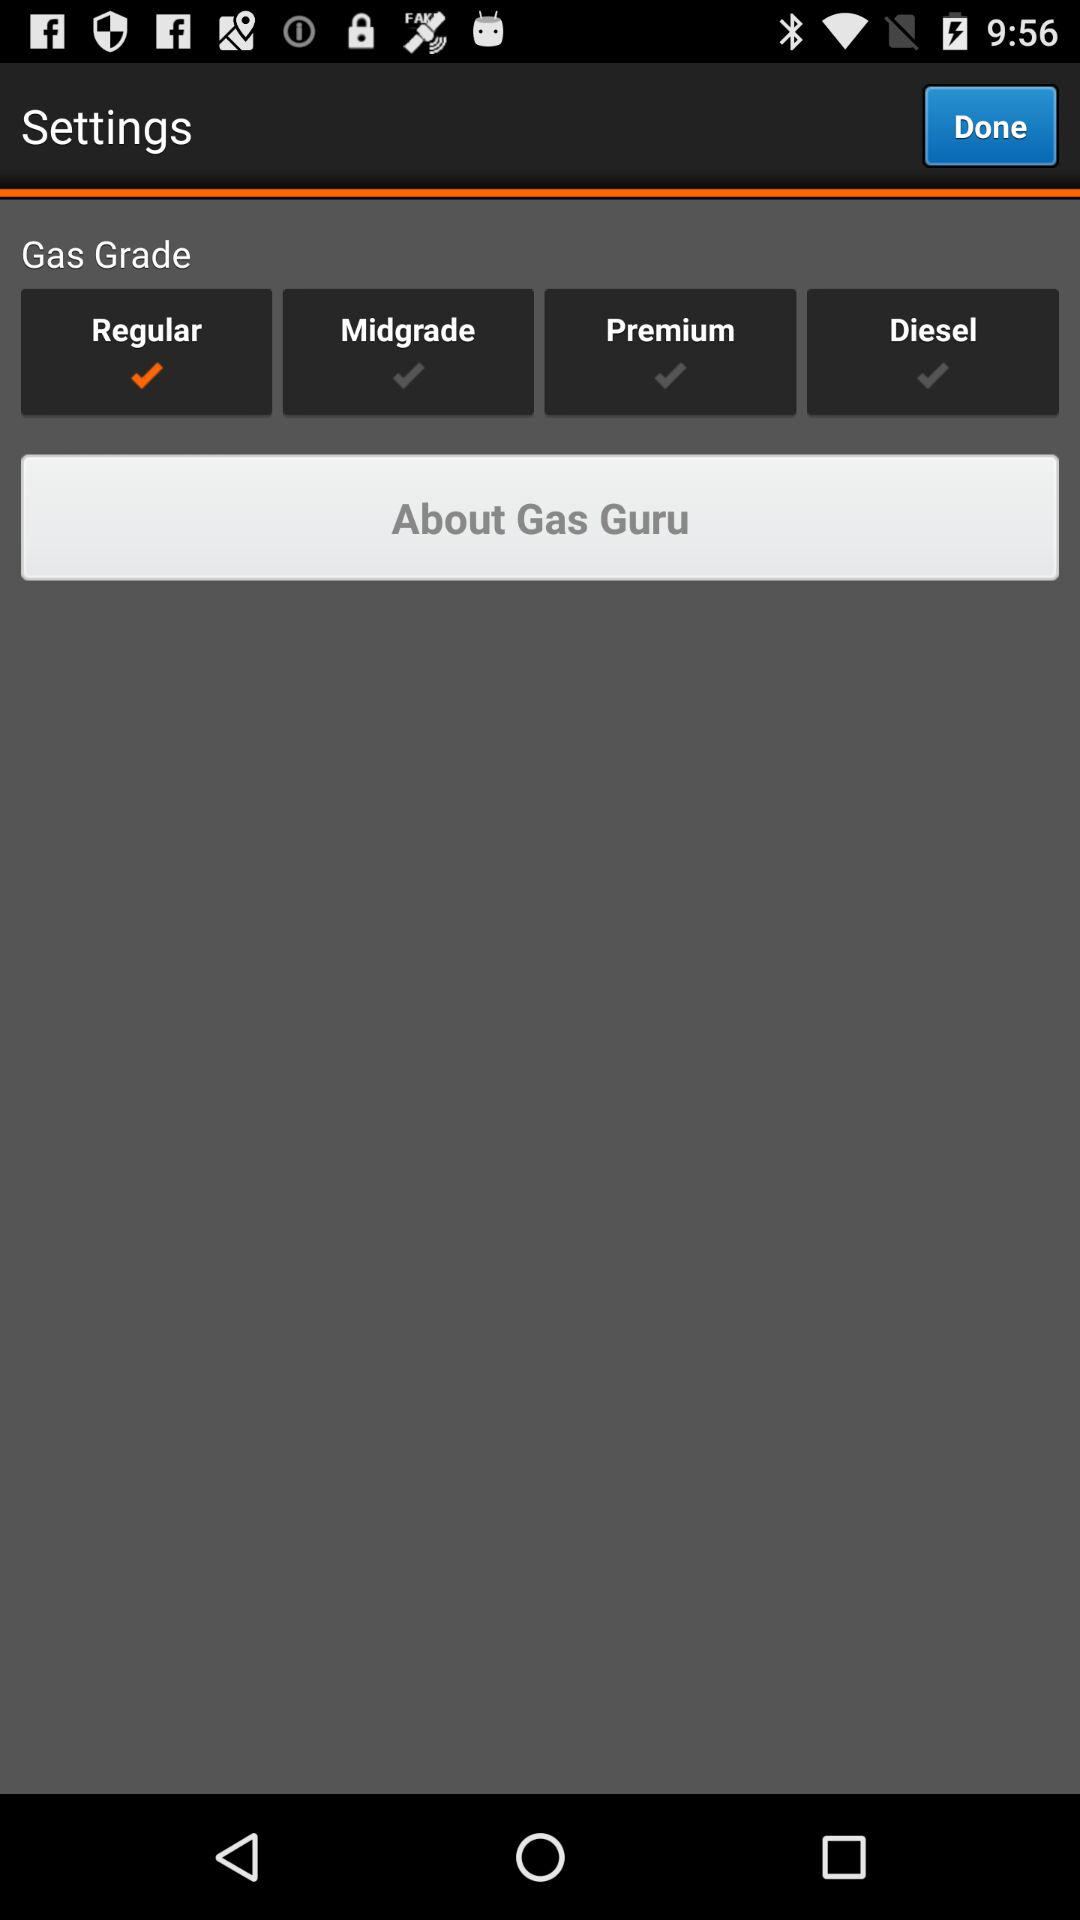How many check marks are there for premium and diesel?
Answer the question using a single word or phrase. 2 